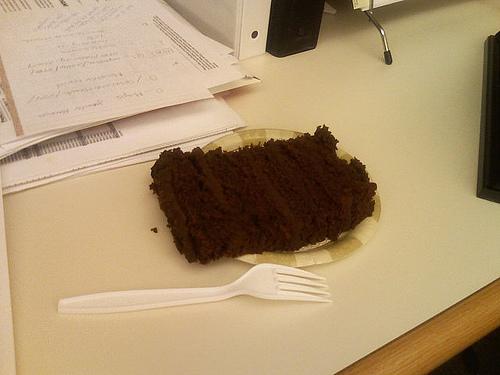What type of food is this?
Concise answer only. Cake. Where is the piece of cake being served?
Short answer required. Office. What kind of food is this?
Answer briefly. Cake. Why is the cake bigger than the plate?
Be succinct. Preference. 